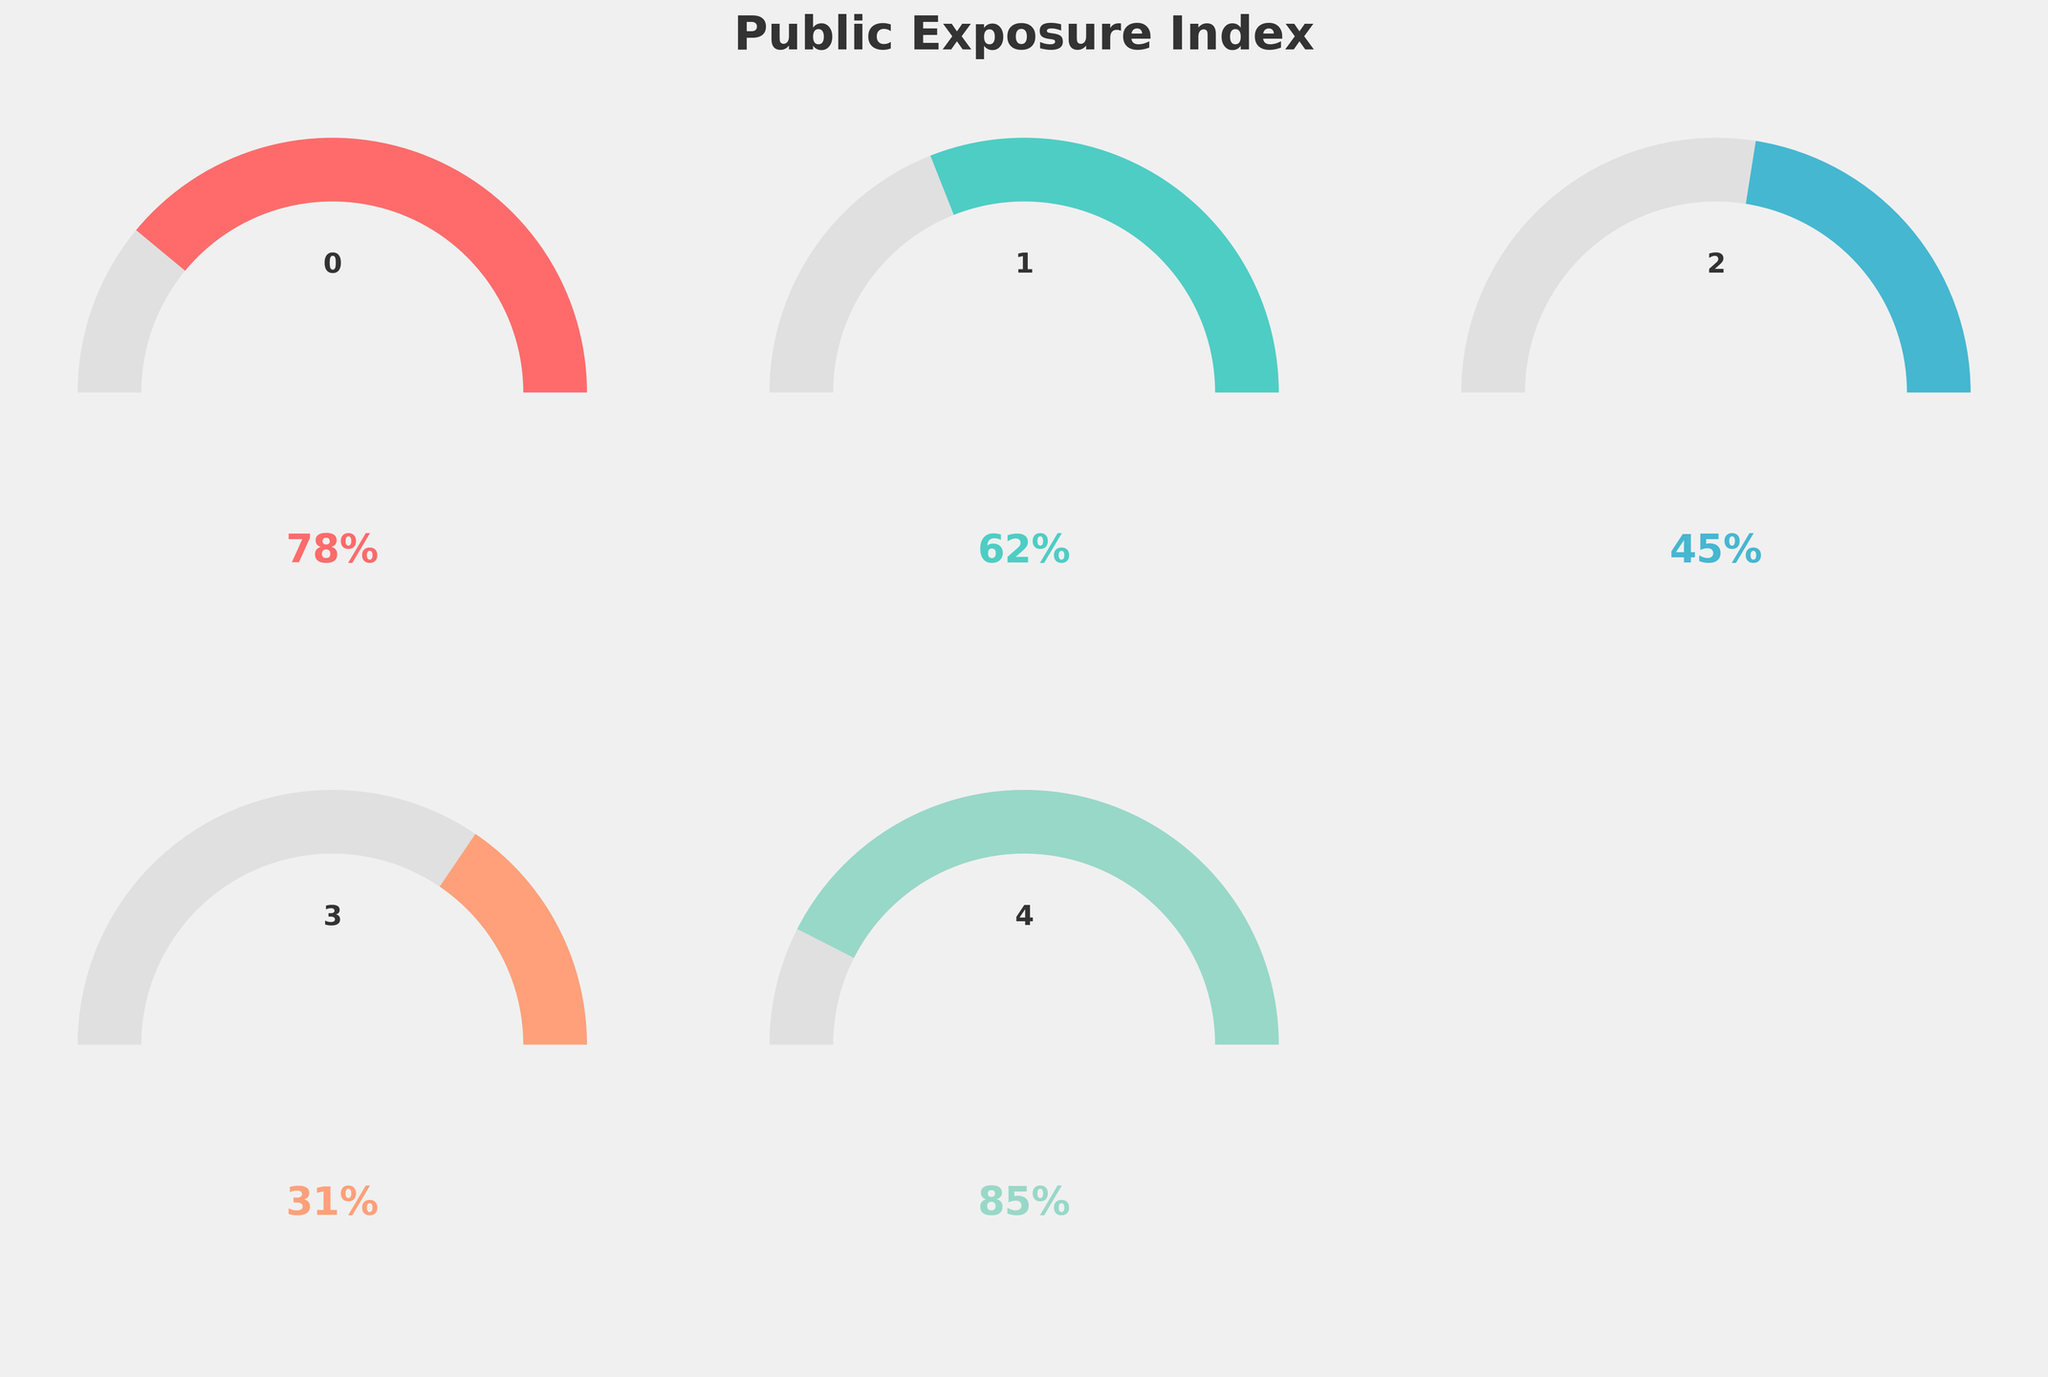Which index has the highest value? The Online Search Volume gauge shows a value of 85%, which is the highest among all the indices displayed in the figure.
Answer: Online Search Volume What is the difference between Media Mentions and Public Appearances? Media Mentions has a value of 78% and Public Appearances has a value of 31%. The difference between them is 78% - 31% = 47%.
Answer: 47% Which index has the lowest value? The Public Appearances gauge shows a value of 31%, which is the lowest among all the indices displayed in the figure.
Answer: Public Appearances What's the average value across all the indices? The values for the indices are 78%, 62%, 45%, 31%, and 85%. Adding these up gives 78 + 62 + 45 + 31 + 85 = 301. Dividing by the number of indices gives 301 / 5 = 60.2%.
Answer: 60.2% Which indices have values above 50%? Media Mentions (78%), Social Media Activity (62%), and Online Search Volume (85%) all have values above 50%.
Answer: Media Mentions, Social Media Activity, Online Search Volume How much higher is Online Search Volume compared to Paparazzi Sightings? Online Search Volume has a value of 85% and Paparazzi Sightings has a value of 45%. The difference is 85% - 45% = 40%.
Answer: 40% What is the range of values displayed in the figure? The maximum value is 85% (Online Search Volume) and the minimum value is 31% (Public Appearances). The range is 85% - 31% = 54%.
Answer: 54% If you summed up the values of Media Mentions and Social Media Activity, what would you get? The values for Media Mentions and Social Media Activity are 78% and 62%, respectively. Summing them gives 78 + 62 = 140%.
Answer: 140% What is the median value of the indices displayed? The values in ascending order are 31%, 45%, 62%, 78%, and 85%. The middle value is 62%, which is the value of Social Media Activity.
Answer: 62% 